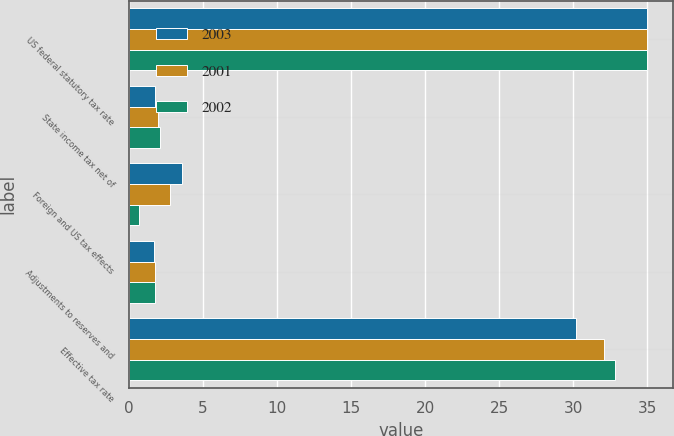<chart> <loc_0><loc_0><loc_500><loc_500><stacked_bar_chart><ecel><fcel>US federal statutory tax rate<fcel>State income tax net of<fcel>Foreign and US tax effects<fcel>Adjustments to reserves and<fcel>Effective tax rate<nl><fcel>2003<fcel>35<fcel>1.8<fcel>3.6<fcel>1.7<fcel>30.2<nl><fcel>2001<fcel>35<fcel>2<fcel>2.8<fcel>1.8<fcel>32.1<nl><fcel>2002<fcel>35<fcel>2.1<fcel>0.7<fcel>1.8<fcel>32.8<nl></chart> 